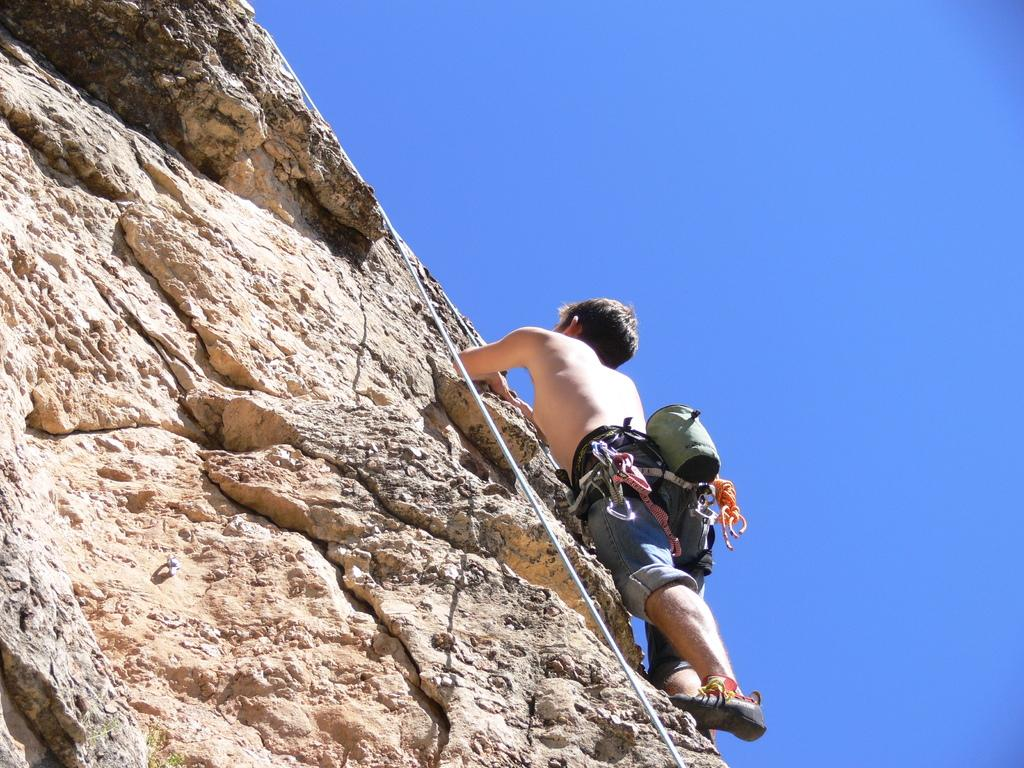Who is the main subject in the image? There is a man in the image. What is the man doing in the image? The man is climbing a rock hill. What can be seen in the background of the image? There is sky visible in the background of the image. What type of fruit is the man holding while climbing the rock hill in the image? There is no fruit present in the image; the man is not holding any fruit while climbing the rock hill. 